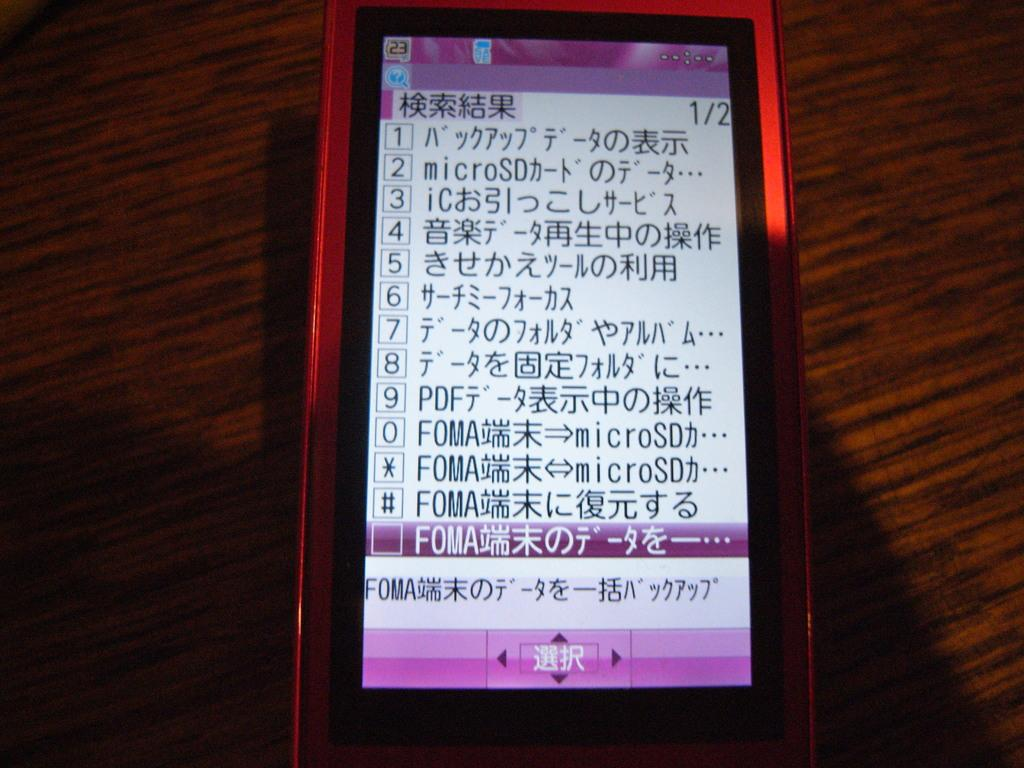<image>
Give a short and clear explanation of the subsequent image. A smartphone with a red case with the number 23 at the edge of the screen 